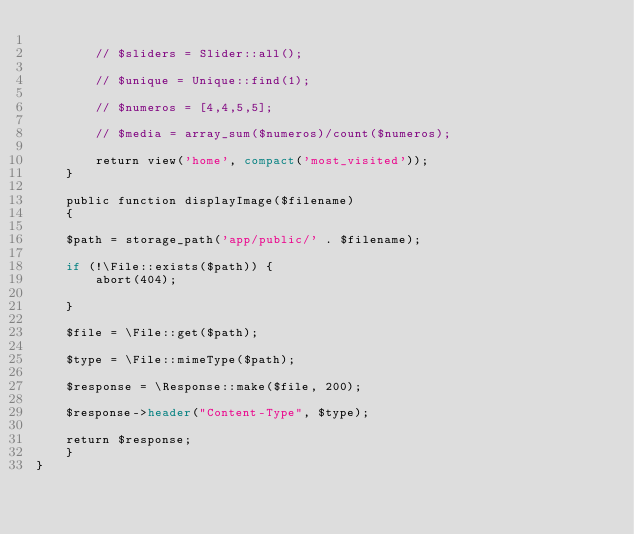<code> <loc_0><loc_0><loc_500><loc_500><_PHP_>
    	// $sliders = Slider::all();

    	// $unique = Unique::find(1);

    	// $numeros = [4,4,5,5];

    	// $media = array_sum($numeros)/count($numeros);

    	return view('home', compact('most_visited'));
    }

    public function displayImage($filename)
    {

    $path = storage_path('app/public/' . $filename);

    if (!\File::exists($path)) {
        abort(404);

    }

    $file = \File::get($path);

    $type = \File::mimeType($path);

    $response = \Response::make($file, 200);

    $response->header("Content-Type", $type); 

    return $response;
    }
}
</code> 